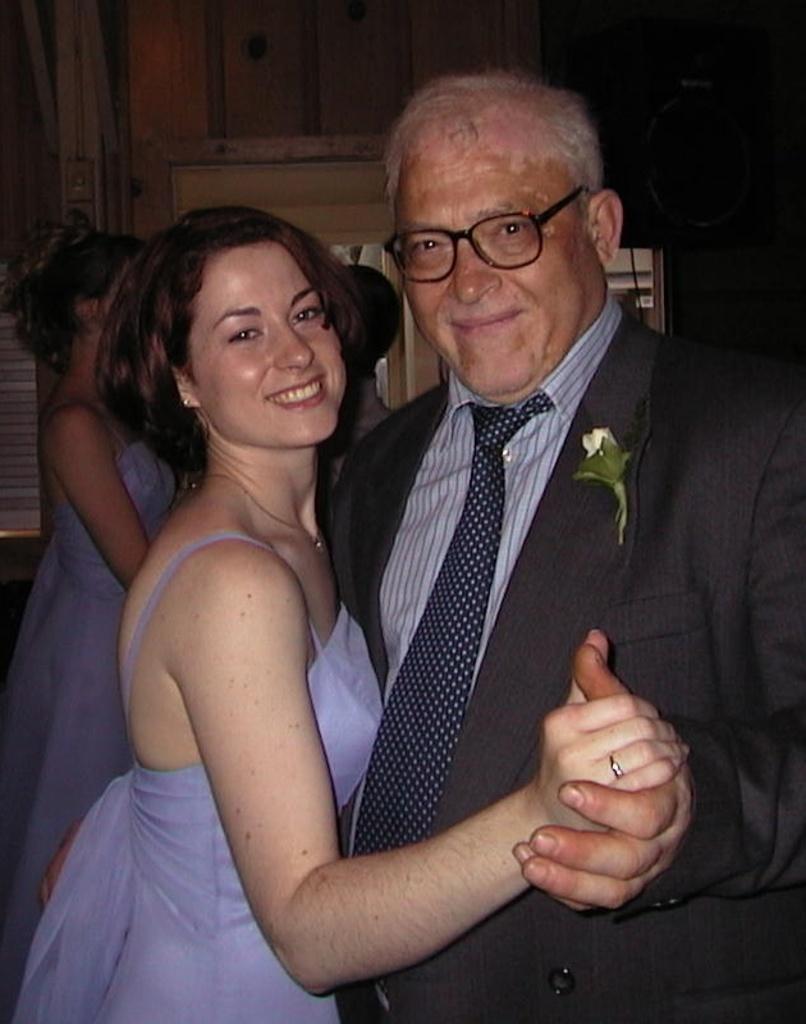In one or two sentences, can you explain what this image depicts? In this picture there is a man who is wearing suit. Beside him there is a woman who is wearing a dress and locket. Both of them are smiling. In the back I can see the couple who are dancing. Beside them I can see the window and door. 